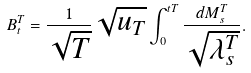<formula> <loc_0><loc_0><loc_500><loc_500>B _ { t } ^ { T } = \frac { 1 } { \sqrt { T } } \sqrt { u _ { T } } \int _ { 0 } ^ { t T } \frac { d M _ { s } ^ { T } } { \sqrt { \lambda ^ { T } _ { s } } } .</formula> 